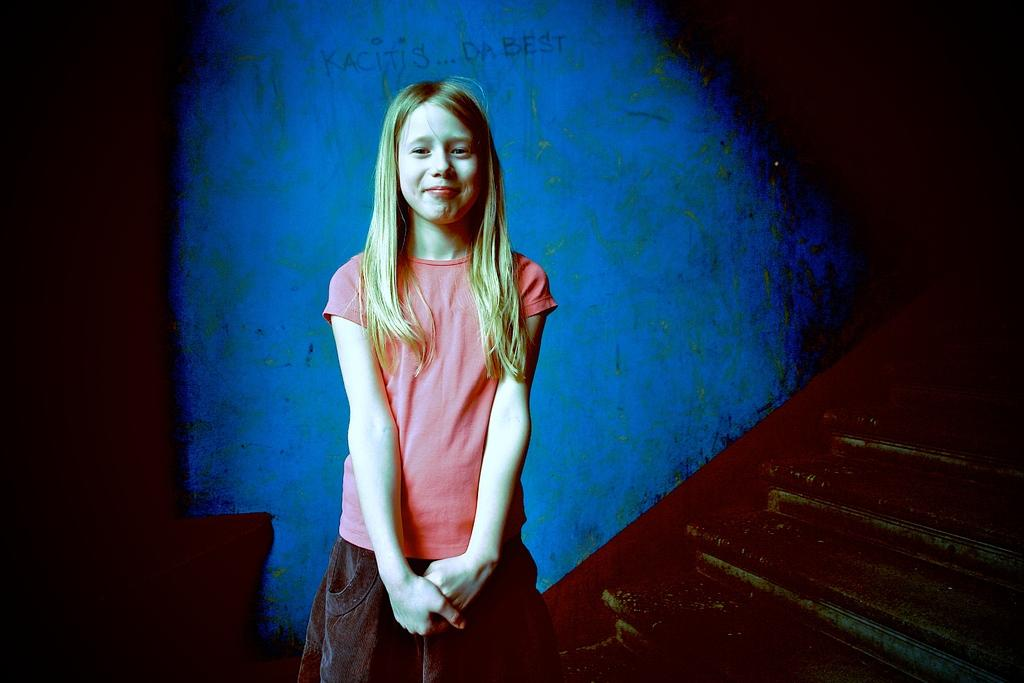What is the girl doing in the image? The girl is standing near the steps in the image. What can be seen in the background behind the girl? There is a blue wall in the background. Is there any text or image on the blue wall? Yes, there is something written on the blue wall. What type of substance is the girl holding in her hand in the image? There is no substance visible in the girl's hand in the image. 